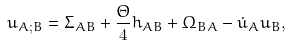<formula> <loc_0><loc_0><loc_500><loc_500>u _ { A ; B } = \Sigma _ { A B } + \frac { \Theta } { 4 } h _ { A B } + \Omega _ { B A } - \dot { u } _ { A } u _ { B } ,</formula> 